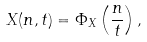<formula> <loc_0><loc_0><loc_500><loc_500>X ( n , t ) = \Phi _ { X } \left ( \frac { n } { t } \right ) ,</formula> 